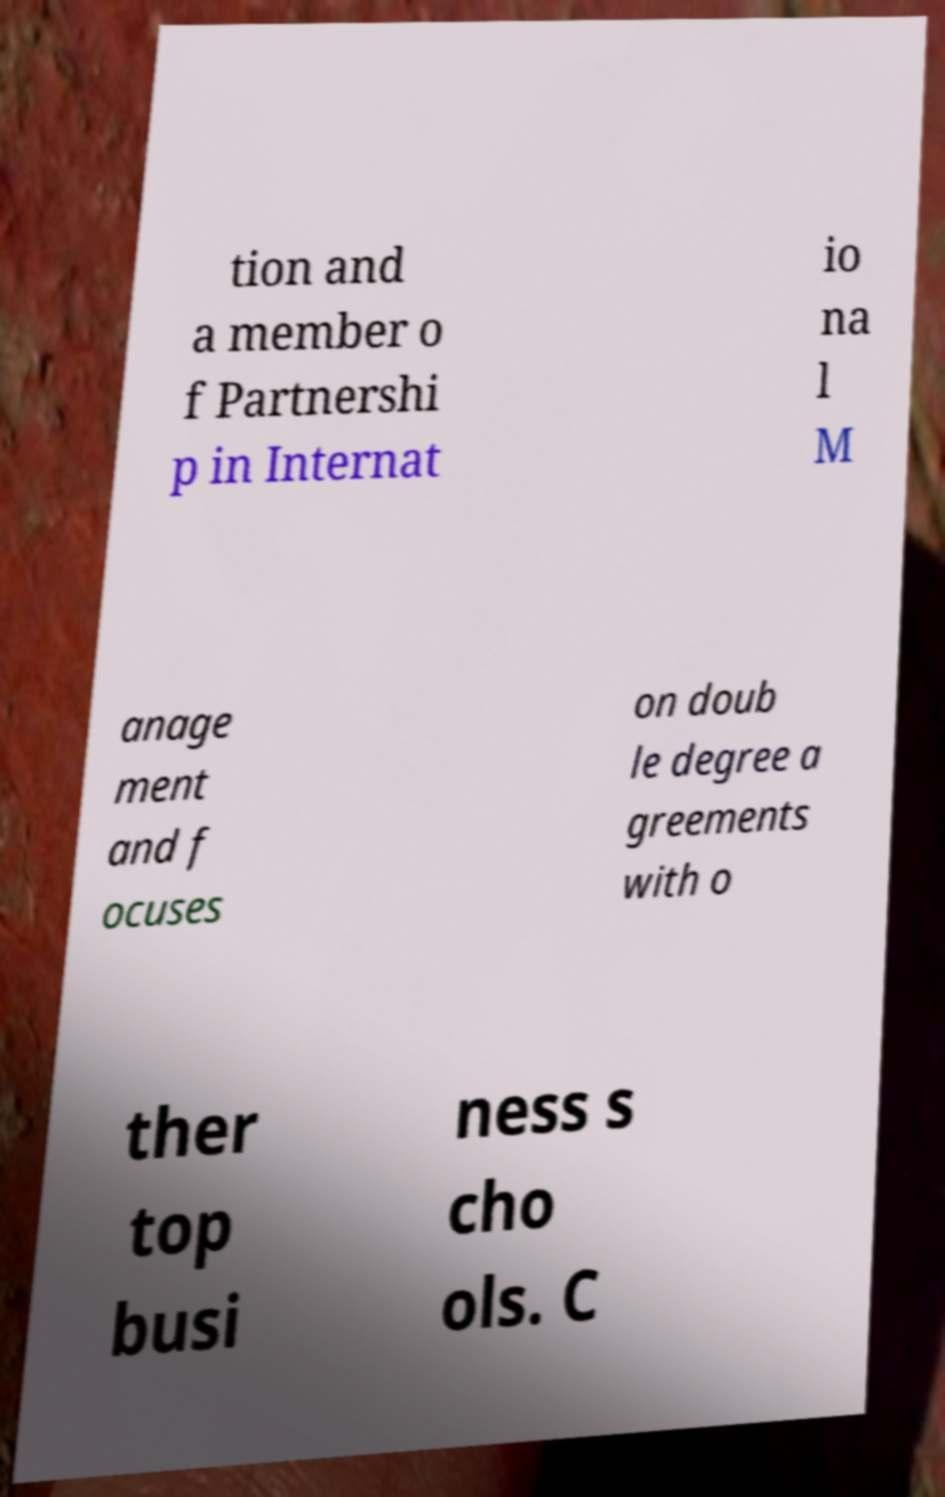Please identify and transcribe the text found in this image. tion and a member o f Partnershi p in Internat io na l M anage ment and f ocuses on doub le degree a greements with o ther top busi ness s cho ols. C 